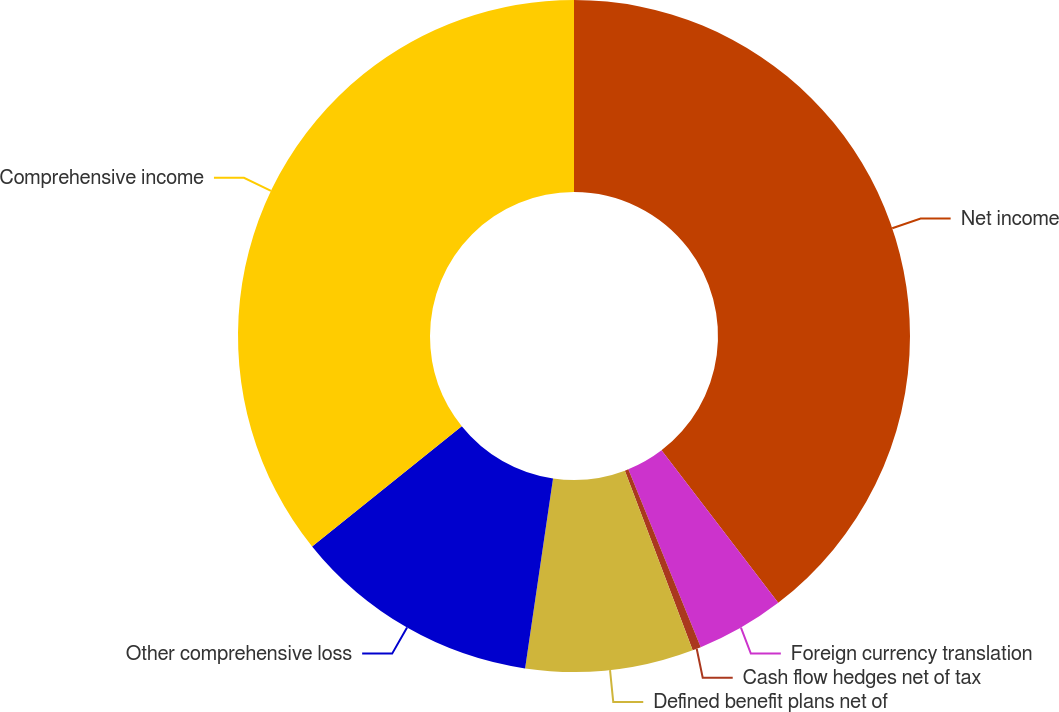<chart> <loc_0><loc_0><loc_500><loc_500><pie_chart><fcel>Net income<fcel>Foreign currency translation<fcel>Cash flow hedges net of tax<fcel>Defined benefit plans net of<fcel>Other comprehensive loss<fcel>Comprehensive income<nl><fcel>39.6%<fcel>4.24%<fcel>0.41%<fcel>8.07%<fcel>11.9%<fcel>35.77%<nl></chart> 